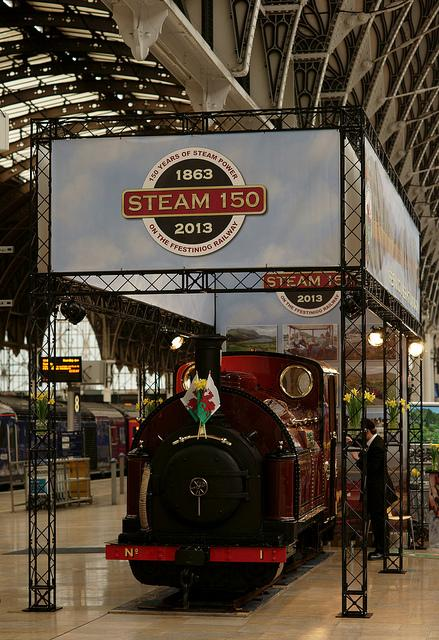What operation should be done with the numbers to arrive at the years of steam power? subtraction 